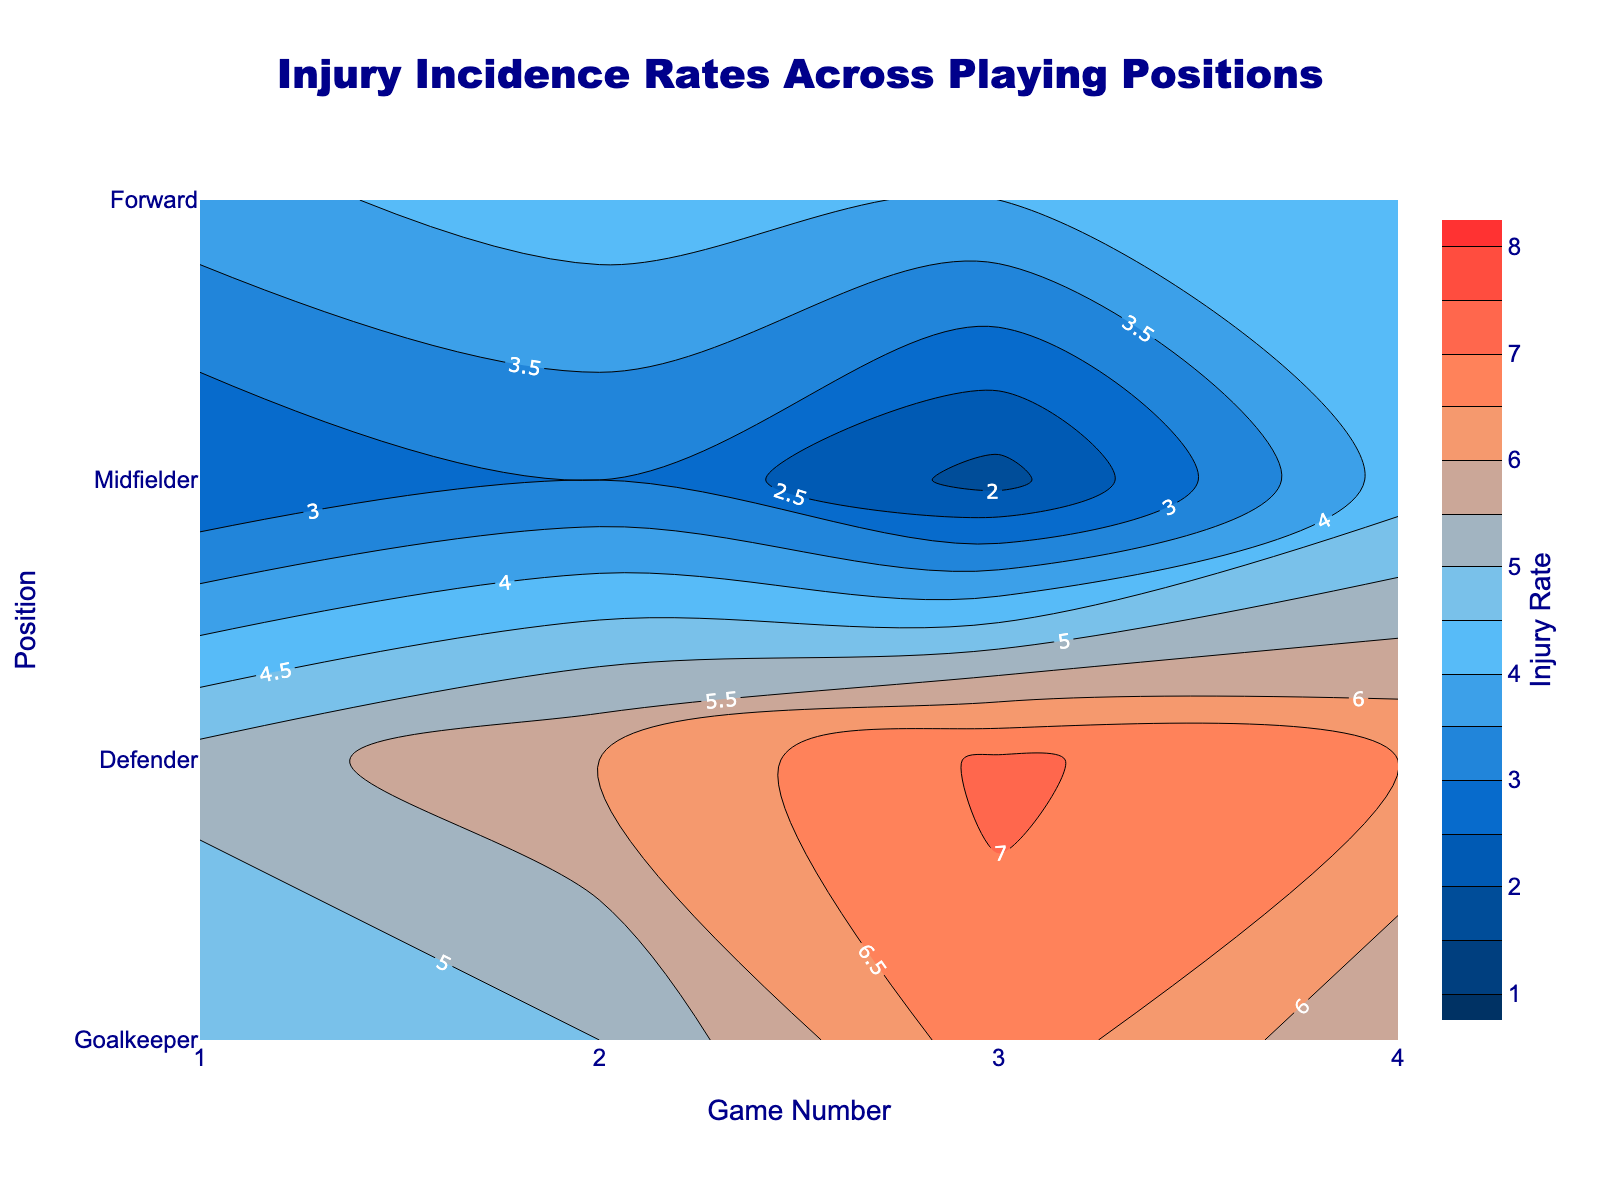What's the title of the figure? The title of the figure is displayed prominently at the top center of the plot, making it easily visible.
Answer: Injury Incidence Rates Across Playing Positions What does the color bar represent? The color bar on the right side of the plot indicates the range of injury rates with different colors representing different rates.
Answer: Injury Rate Which position has the highest injury rate in Game 3? By examining the contour plot at the location corresponding to Game 3 on the x-axis and observing the color and contour lines associated with each position, we can determine the highest point.
Answer: Forward How does the injury rate for Goalkeeper compare between Game 1 and Game 4? By locating the contour levels for Goalkeeper at Game 1 and Game 4 on the x-axis, we can compare their respective injury rates.
Answer: 2.5 (Game 1) is less than 4.2 (Game 4) On average, how do injury rates for Midfielders change from Game 1 to Game 4? Calculate the average of the Injury Rate for Midfielders across all games, then observe the contour lines' progression and colors from Game 1 to Game 4.
Answer: 4.15 Which playing position shows the most variability in injury rates across the games? By comparing the range of contour levels and colors at each position across all game numbers, we can determine which position shows the most fluctuation.
Answer: Forward What is the range of injury rates observed for Defenders? By examining the minimum and maximum contour levels and corresponding colors for Defenders across all games, we can determine their range.
Answer: 4.5 to 6.8 How many injury rates are represented in the color scale? By counting the number of distinct contour levels delineated by the color bar's legend, we can determine the number of rates represented.
Answer: Approximately 15 Which position has the lowest injury rate in Game 2, and what is that rate? By checking the contour plot at the x-axis for Game 2 and finding the lowest point among all positions while noting the color or contour line representing it.
Answer: Goalkeeper, 3.0 